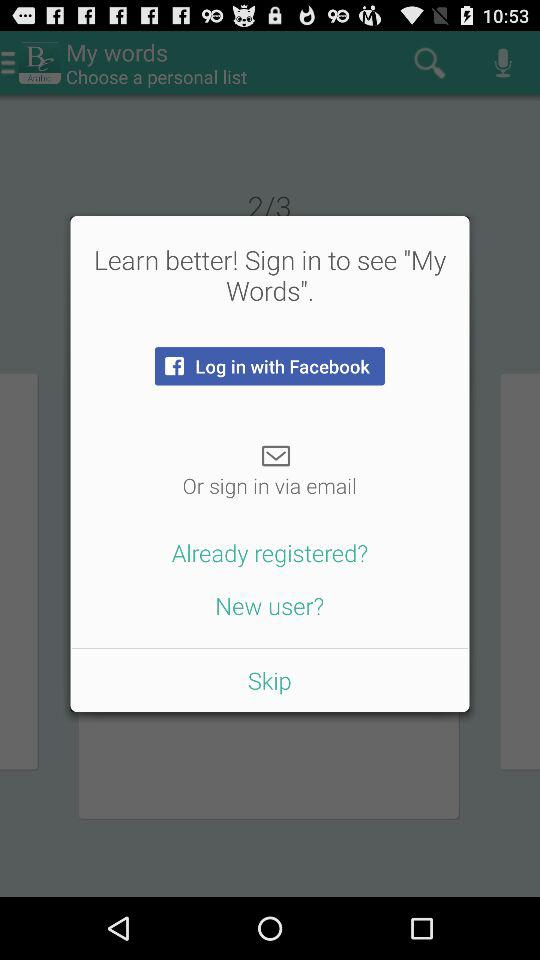What are the different options available for login? What are the different options available for logging in? The different options available for logging in are "Facebook" and "email". 